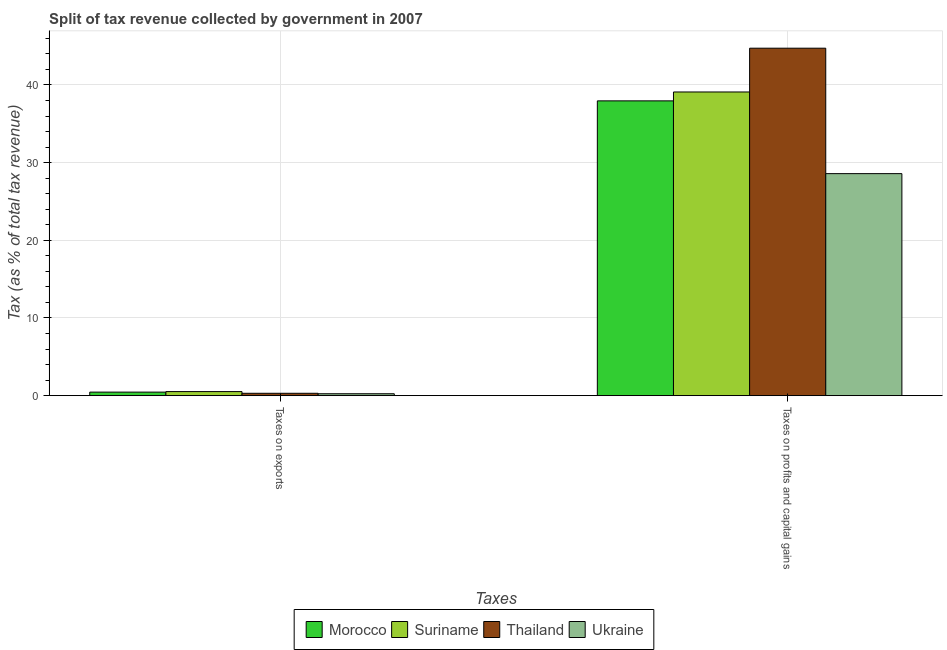How many different coloured bars are there?
Offer a very short reply. 4. Are the number of bars per tick equal to the number of legend labels?
Offer a terse response. Yes. Are the number of bars on each tick of the X-axis equal?
Keep it short and to the point. Yes. How many bars are there on the 1st tick from the left?
Give a very brief answer. 4. What is the label of the 2nd group of bars from the left?
Your response must be concise. Taxes on profits and capital gains. What is the percentage of revenue obtained from taxes on exports in Morocco?
Your answer should be compact. 0.45. Across all countries, what is the maximum percentage of revenue obtained from taxes on profits and capital gains?
Offer a very short reply. 44.74. Across all countries, what is the minimum percentage of revenue obtained from taxes on exports?
Provide a short and direct response. 0.25. In which country was the percentage of revenue obtained from taxes on profits and capital gains maximum?
Provide a succinct answer. Thailand. In which country was the percentage of revenue obtained from taxes on profits and capital gains minimum?
Keep it short and to the point. Ukraine. What is the total percentage of revenue obtained from taxes on profits and capital gains in the graph?
Offer a terse response. 150.38. What is the difference between the percentage of revenue obtained from taxes on profits and capital gains in Ukraine and that in Suriname?
Offer a very short reply. -10.51. What is the difference between the percentage of revenue obtained from taxes on profits and capital gains in Morocco and the percentage of revenue obtained from taxes on exports in Thailand?
Make the answer very short. 37.65. What is the average percentage of revenue obtained from taxes on profits and capital gains per country?
Your answer should be very brief. 37.59. What is the difference between the percentage of revenue obtained from taxes on exports and percentage of revenue obtained from taxes on profits and capital gains in Thailand?
Ensure brevity in your answer.  -44.43. What is the ratio of the percentage of revenue obtained from taxes on profits and capital gains in Morocco to that in Ukraine?
Offer a very short reply. 1.33. Is the percentage of revenue obtained from taxes on profits and capital gains in Thailand less than that in Suriname?
Ensure brevity in your answer.  No. What does the 1st bar from the left in Taxes on exports represents?
Make the answer very short. Morocco. What does the 1st bar from the right in Taxes on exports represents?
Your answer should be very brief. Ukraine. Are all the bars in the graph horizontal?
Your answer should be compact. No. How many countries are there in the graph?
Your answer should be very brief. 4. What is the difference between two consecutive major ticks on the Y-axis?
Your answer should be compact. 10. Does the graph contain any zero values?
Offer a very short reply. No. Does the graph contain grids?
Make the answer very short. Yes. Where does the legend appear in the graph?
Provide a short and direct response. Bottom center. What is the title of the graph?
Your response must be concise. Split of tax revenue collected by government in 2007. Does "Argentina" appear as one of the legend labels in the graph?
Offer a very short reply. No. What is the label or title of the X-axis?
Keep it short and to the point. Taxes. What is the label or title of the Y-axis?
Your response must be concise. Tax (as % of total tax revenue). What is the Tax (as % of total tax revenue) of Morocco in Taxes on exports?
Provide a succinct answer. 0.45. What is the Tax (as % of total tax revenue) in Suriname in Taxes on exports?
Offer a very short reply. 0.52. What is the Tax (as % of total tax revenue) of Thailand in Taxes on exports?
Provide a succinct answer. 0.3. What is the Tax (as % of total tax revenue) of Ukraine in Taxes on exports?
Your answer should be compact. 0.25. What is the Tax (as % of total tax revenue) in Morocco in Taxes on profits and capital gains?
Offer a very short reply. 37.96. What is the Tax (as % of total tax revenue) in Suriname in Taxes on profits and capital gains?
Provide a succinct answer. 39.1. What is the Tax (as % of total tax revenue) of Thailand in Taxes on profits and capital gains?
Your response must be concise. 44.74. What is the Tax (as % of total tax revenue) of Ukraine in Taxes on profits and capital gains?
Your response must be concise. 28.59. Across all Taxes, what is the maximum Tax (as % of total tax revenue) of Morocco?
Your answer should be compact. 37.96. Across all Taxes, what is the maximum Tax (as % of total tax revenue) of Suriname?
Ensure brevity in your answer.  39.1. Across all Taxes, what is the maximum Tax (as % of total tax revenue) of Thailand?
Your answer should be compact. 44.74. Across all Taxes, what is the maximum Tax (as % of total tax revenue) in Ukraine?
Make the answer very short. 28.59. Across all Taxes, what is the minimum Tax (as % of total tax revenue) in Morocco?
Offer a terse response. 0.45. Across all Taxes, what is the minimum Tax (as % of total tax revenue) of Suriname?
Offer a very short reply. 0.52. Across all Taxes, what is the minimum Tax (as % of total tax revenue) of Thailand?
Your answer should be very brief. 0.3. Across all Taxes, what is the minimum Tax (as % of total tax revenue) in Ukraine?
Offer a terse response. 0.25. What is the total Tax (as % of total tax revenue) of Morocco in the graph?
Provide a short and direct response. 38.41. What is the total Tax (as % of total tax revenue) in Suriname in the graph?
Your answer should be very brief. 39.62. What is the total Tax (as % of total tax revenue) of Thailand in the graph?
Your answer should be very brief. 45.04. What is the total Tax (as % of total tax revenue) of Ukraine in the graph?
Ensure brevity in your answer.  28.83. What is the difference between the Tax (as % of total tax revenue) in Morocco in Taxes on exports and that in Taxes on profits and capital gains?
Ensure brevity in your answer.  -37.5. What is the difference between the Tax (as % of total tax revenue) of Suriname in Taxes on exports and that in Taxes on profits and capital gains?
Your answer should be very brief. -38.58. What is the difference between the Tax (as % of total tax revenue) in Thailand in Taxes on exports and that in Taxes on profits and capital gains?
Keep it short and to the point. -44.43. What is the difference between the Tax (as % of total tax revenue) of Ukraine in Taxes on exports and that in Taxes on profits and capital gains?
Provide a short and direct response. -28.34. What is the difference between the Tax (as % of total tax revenue) in Morocco in Taxes on exports and the Tax (as % of total tax revenue) in Suriname in Taxes on profits and capital gains?
Offer a very short reply. -38.65. What is the difference between the Tax (as % of total tax revenue) in Morocco in Taxes on exports and the Tax (as % of total tax revenue) in Thailand in Taxes on profits and capital gains?
Provide a succinct answer. -44.28. What is the difference between the Tax (as % of total tax revenue) in Morocco in Taxes on exports and the Tax (as % of total tax revenue) in Ukraine in Taxes on profits and capital gains?
Offer a terse response. -28.13. What is the difference between the Tax (as % of total tax revenue) in Suriname in Taxes on exports and the Tax (as % of total tax revenue) in Thailand in Taxes on profits and capital gains?
Provide a short and direct response. -44.21. What is the difference between the Tax (as % of total tax revenue) in Suriname in Taxes on exports and the Tax (as % of total tax revenue) in Ukraine in Taxes on profits and capital gains?
Offer a very short reply. -28.06. What is the difference between the Tax (as % of total tax revenue) in Thailand in Taxes on exports and the Tax (as % of total tax revenue) in Ukraine in Taxes on profits and capital gains?
Give a very brief answer. -28.28. What is the average Tax (as % of total tax revenue) of Morocco per Taxes?
Give a very brief answer. 19.2. What is the average Tax (as % of total tax revenue) in Suriname per Taxes?
Provide a short and direct response. 19.81. What is the average Tax (as % of total tax revenue) in Thailand per Taxes?
Make the answer very short. 22.52. What is the average Tax (as % of total tax revenue) in Ukraine per Taxes?
Make the answer very short. 14.42. What is the difference between the Tax (as % of total tax revenue) of Morocco and Tax (as % of total tax revenue) of Suriname in Taxes on exports?
Provide a short and direct response. -0.07. What is the difference between the Tax (as % of total tax revenue) in Morocco and Tax (as % of total tax revenue) in Thailand in Taxes on exports?
Offer a very short reply. 0.15. What is the difference between the Tax (as % of total tax revenue) in Morocco and Tax (as % of total tax revenue) in Ukraine in Taxes on exports?
Provide a short and direct response. 0.21. What is the difference between the Tax (as % of total tax revenue) in Suriname and Tax (as % of total tax revenue) in Thailand in Taxes on exports?
Your answer should be very brief. 0.22. What is the difference between the Tax (as % of total tax revenue) of Suriname and Tax (as % of total tax revenue) of Ukraine in Taxes on exports?
Ensure brevity in your answer.  0.28. What is the difference between the Tax (as % of total tax revenue) in Thailand and Tax (as % of total tax revenue) in Ukraine in Taxes on exports?
Offer a terse response. 0.06. What is the difference between the Tax (as % of total tax revenue) in Morocco and Tax (as % of total tax revenue) in Suriname in Taxes on profits and capital gains?
Your answer should be compact. -1.14. What is the difference between the Tax (as % of total tax revenue) of Morocco and Tax (as % of total tax revenue) of Thailand in Taxes on profits and capital gains?
Offer a terse response. -6.78. What is the difference between the Tax (as % of total tax revenue) in Morocco and Tax (as % of total tax revenue) in Ukraine in Taxes on profits and capital gains?
Your answer should be compact. 9.37. What is the difference between the Tax (as % of total tax revenue) in Suriname and Tax (as % of total tax revenue) in Thailand in Taxes on profits and capital gains?
Keep it short and to the point. -5.64. What is the difference between the Tax (as % of total tax revenue) of Suriname and Tax (as % of total tax revenue) of Ukraine in Taxes on profits and capital gains?
Make the answer very short. 10.51. What is the difference between the Tax (as % of total tax revenue) in Thailand and Tax (as % of total tax revenue) in Ukraine in Taxes on profits and capital gains?
Offer a terse response. 16.15. What is the ratio of the Tax (as % of total tax revenue) in Morocco in Taxes on exports to that in Taxes on profits and capital gains?
Offer a terse response. 0.01. What is the ratio of the Tax (as % of total tax revenue) in Suriname in Taxes on exports to that in Taxes on profits and capital gains?
Your answer should be very brief. 0.01. What is the ratio of the Tax (as % of total tax revenue) in Thailand in Taxes on exports to that in Taxes on profits and capital gains?
Make the answer very short. 0.01. What is the ratio of the Tax (as % of total tax revenue) of Ukraine in Taxes on exports to that in Taxes on profits and capital gains?
Keep it short and to the point. 0.01. What is the difference between the highest and the second highest Tax (as % of total tax revenue) in Morocco?
Your answer should be very brief. 37.5. What is the difference between the highest and the second highest Tax (as % of total tax revenue) of Suriname?
Your answer should be very brief. 38.58. What is the difference between the highest and the second highest Tax (as % of total tax revenue) of Thailand?
Make the answer very short. 44.43. What is the difference between the highest and the second highest Tax (as % of total tax revenue) of Ukraine?
Provide a succinct answer. 28.34. What is the difference between the highest and the lowest Tax (as % of total tax revenue) in Morocco?
Keep it short and to the point. 37.5. What is the difference between the highest and the lowest Tax (as % of total tax revenue) in Suriname?
Your answer should be very brief. 38.58. What is the difference between the highest and the lowest Tax (as % of total tax revenue) of Thailand?
Your response must be concise. 44.43. What is the difference between the highest and the lowest Tax (as % of total tax revenue) of Ukraine?
Provide a succinct answer. 28.34. 